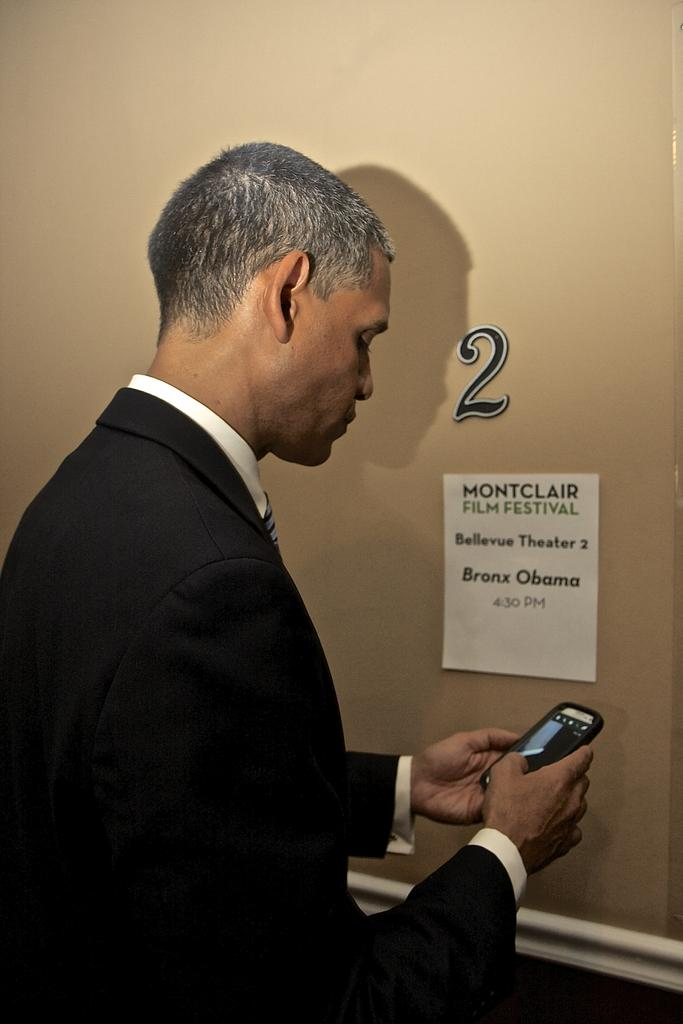Who is present in the image? There is a man in the image. What is the man doing in the image? The man is standing and checking his mobile phone. What can be seen in the background of the image? There is a paper and a sticker with the number 2 on the wall in the background. What is the taste of the fire in the image? There is no fire present in the image, so it is not possible to determine its taste. 